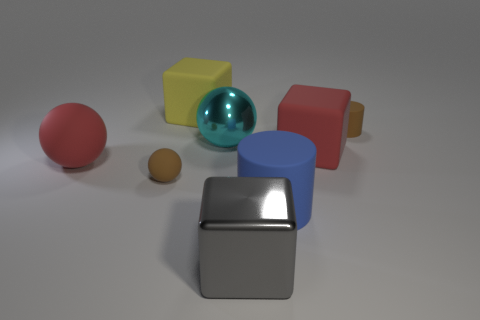Subtract all rubber spheres. How many spheres are left? 1 Subtract all spheres. How many objects are left? 5 Add 1 cyan metallic objects. How many objects exist? 9 Subtract all blue cylinders. How many yellow spheres are left? 0 Subtract all big red rubber objects. Subtract all yellow rubber cubes. How many objects are left? 5 Add 6 tiny rubber spheres. How many tiny rubber spheres are left? 7 Add 1 big cyan rubber things. How many big cyan rubber things exist? 1 Subtract all brown spheres. How many spheres are left? 2 Subtract 1 gray cubes. How many objects are left? 7 Subtract 3 balls. How many balls are left? 0 